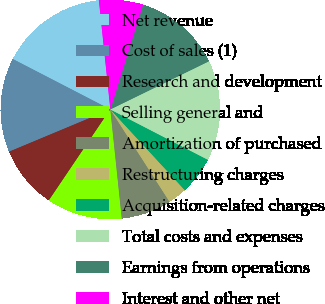Convert chart. <chart><loc_0><loc_0><loc_500><loc_500><pie_chart><fcel>Net revenue<fcel>Cost of sales (1)<fcel>Research and development<fcel>Selling general and<fcel>Amortization of purchased<fcel>Restructuring charges<fcel>Acquisition-related charges<fcel>Total costs and expenses<fcel>Earnings from operations<fcel>Interest and other net<nl><fcel>15.74%<fcel>13.89%<fcel>9.26%<fcel>11.11%<fcel>7.41%<fcel>2.78%<fcel>5.56%<fcel>14.81%<fcel>12.96%<fcel>6.48%<nl></chart> 